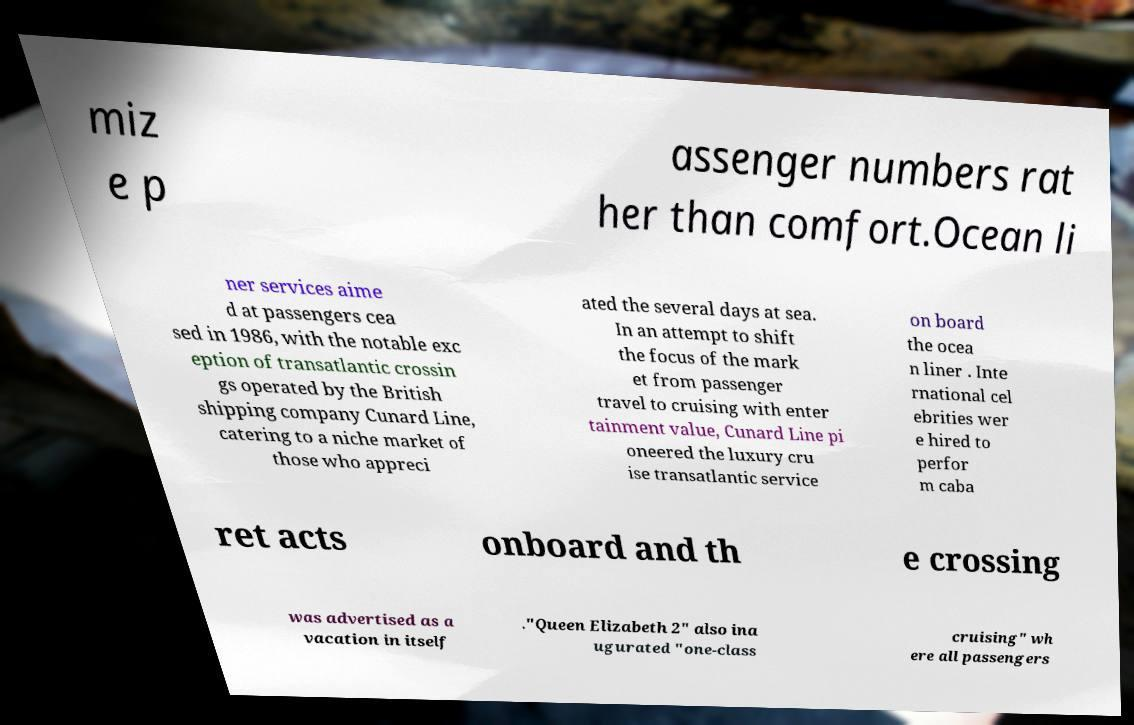Could you assist in decoding the text presented in this image and type it out clearly? miz e p assenger numbers rat her than comfort.Ocean li ner services aime d at passengers cea sed in 1986, with the notable exc eption of transatlantic crossin gs operated by the British shipping company Cunard Line, catering to a niche market of those who appreci ated the several days at sea. In an attempt to shift the focus of the mark et from passenger travel to cruising with enter tainment value, Cunard Line pi oneered the luxury cru ise transatlantic service on board the ocea n liner . Inte rnational cel ebrities wer e hired to perfor m caba ret acts onboard and th e crossing was advertised as a vacation in itself ."Queen Elizabeth 2" also ina ugurated "one-class cruising" wh ere all passengers 